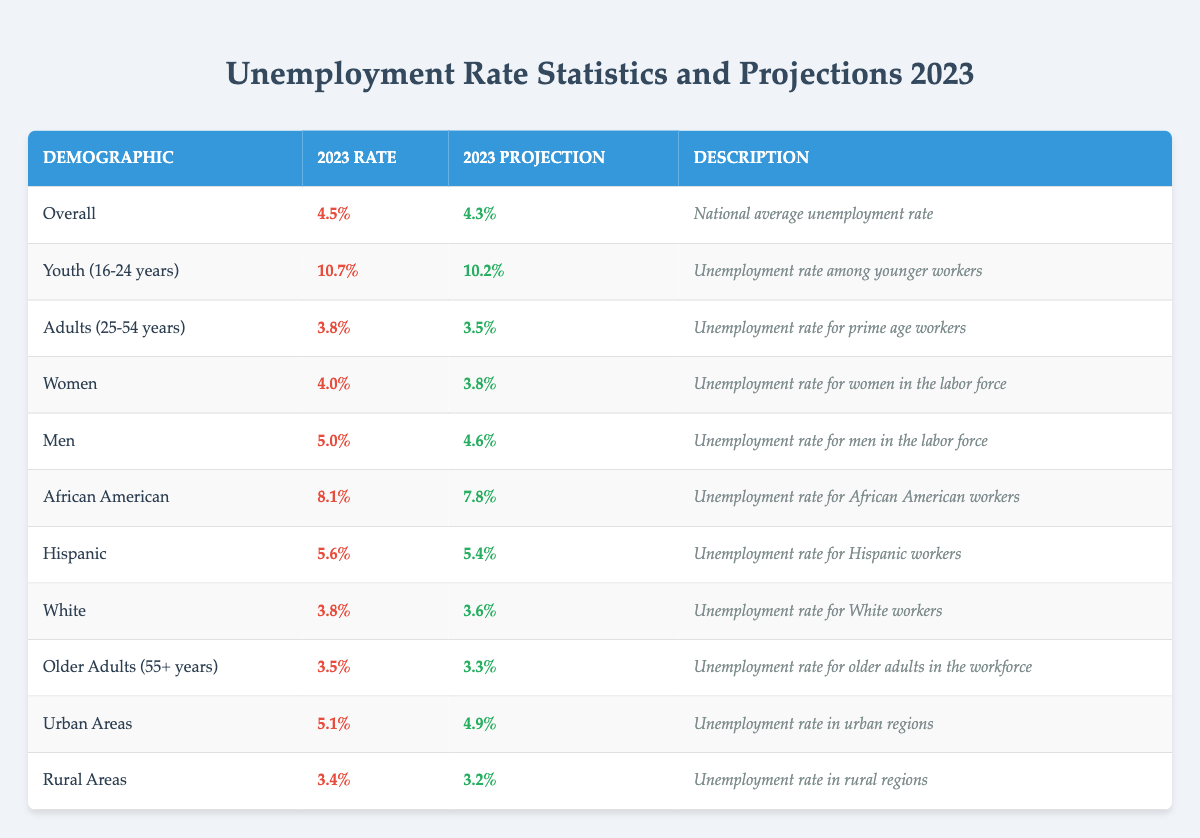What is the unemployment rate for youth aged 16-24 in 2023? The table shows the unemployment rate for youth (16-24 years) as 10.7% for 2023.
Answer: 10.7% What is the projected unemployment rate for women in 2023? The table indicates that the projected unemployment rate for women in 2023 is 3.8%.
Answer: 3.8% Which demographic has the highest unemployment rate in 2023? According to the table, the demographic with the highest unemployment rate in 2023 is African American, with a rate of 8.1%.
Answer: African American What is the difference between the unemployment rates for men and women in 2023? The unemployment rate for men is 5.0%, and for women, it is 4.0%. The difference is 5.0% - 4.0% = 1.0%.
Answer: 1.0% What is the average unemployment rate projected for urban and rural areas in 2023? The projected unemployment rates are 4.9% for urban areas and 3.2% for rural areas. The average is (4.9% + 3.2%) / 2 = 4.05%.
Answer: 4.05% Is the unemployment rate for older adults (55+ years) higher than that for adults aged 25-54 in 2023? The unemployment rate for older adults (3.5%) is lower than that for adults (25-54 years) (3.8%). Thus, the statement is false.
Answer: No What is the projected change in the unemployment rate for youth (16-24 years) from 2023 to the projection? The 2023 rate is 10.7%, and the projection is 10.2%. The change is 10.7% - 10.2% = 0.5%.
Answer: 0.5% For which demographic is the unemployment rate projected to decrease the least in 2023? The unemployment rate for men is projected to decrease from 5.0% to 4.6%, a change of 0.4%, which is the least among all groups.
Answer: Men What is the difference in unemployment rates between rural and urban areas in 2023? The unemployment rate for urban areas is 5.1%, and for rural areas, it is 3.4%. The difference is 5.1% - 3.4% = 1.7%.
Answer: 1.7% What demographic has a lower unemployment rate in 2023: Hispanic or White? The unemployment rate for Hispanic workers is 5.6%, while for White workers, it is 3.8%. Hence, White workers have a lower unemployment rate.
Answer: White If the overall unemployment rate for 2023 is 4.5%, how does this compare with the unemployment rate for adults (25-54 years)? The overall rate is 4.5% while the rate for adults (25-54 years) is 3.8%, which is lower than the overall average.
Answer: Lower 